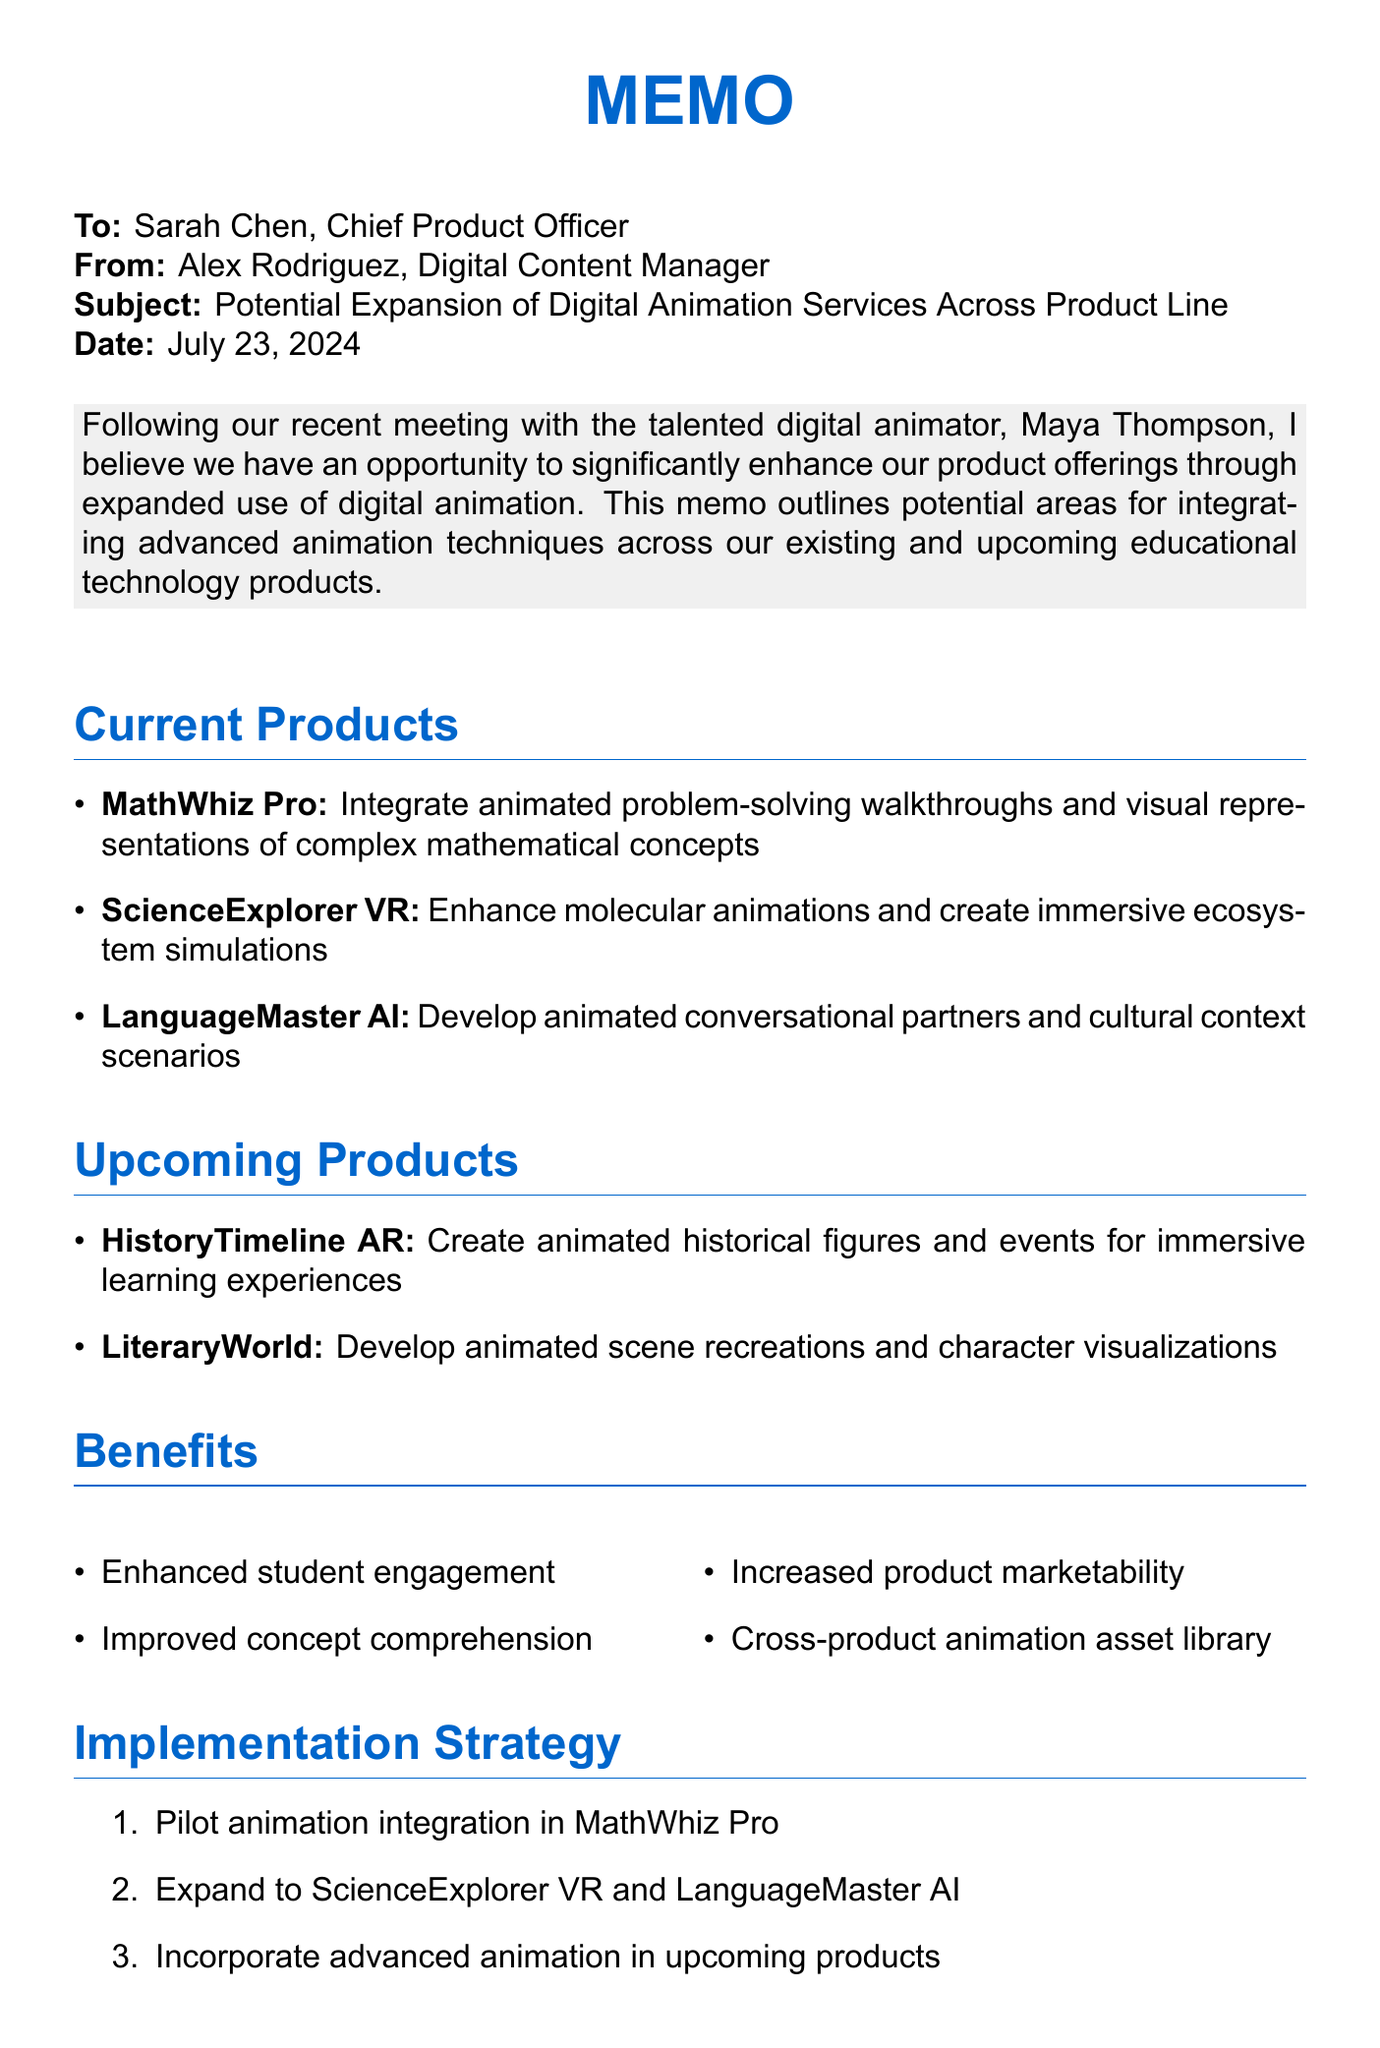What is the name of the Chief Product Officer? The document specifies the recipient as Sarah Chen, who holds the title of Chief Product Officer.
Answer: Sarah Chen What project is in the pilot phase for animation integration? The implementation strategy indicates that MathWhiz Pro is set for pilot animation integration.
Answer: MathWhiz Pro What software will be required for the animation expansion? The document lists Adobe Creative Suite, Autodesk Maya, and Blender as the necessary software for the project.
Answer: Adobe Creative Suite, Autodesk Maya, Blender How much is the Year 1 budget estimate? The budget estimate section states that the Year 1 budget is $750,000.
Answer: $750,000 What are the timeline phases for the full rollout? The timeline outlines that the full rollout is scheduled for Q2 2024, indicating when the entire project will be operational.
Answer: Q2 2024 What is one of the upcoming products mentioned in the memo? The memo includes HistoryTimeline AR among the upcoming products that will have animation integrated.
Answer: HistoryTimeline AR What are the benefits of integrating digital animation listed in the document? The benefits section highlights enhanced student engagement, improved comprehension, and increased marketability among others.
Answer: Enhanced student engagement, improved comprehension, increased marketability How many personnel are required for resource needs? The document states that the project requires two full-time animators and one project manager.
Answer: 2 full-time animators and 1 project manager What is the next step regarding collaboration? The document specifies scheduling a meeting with Maya Thompson as a next step in the project.
Answer: Schedule a meeting with Maya Thompson 